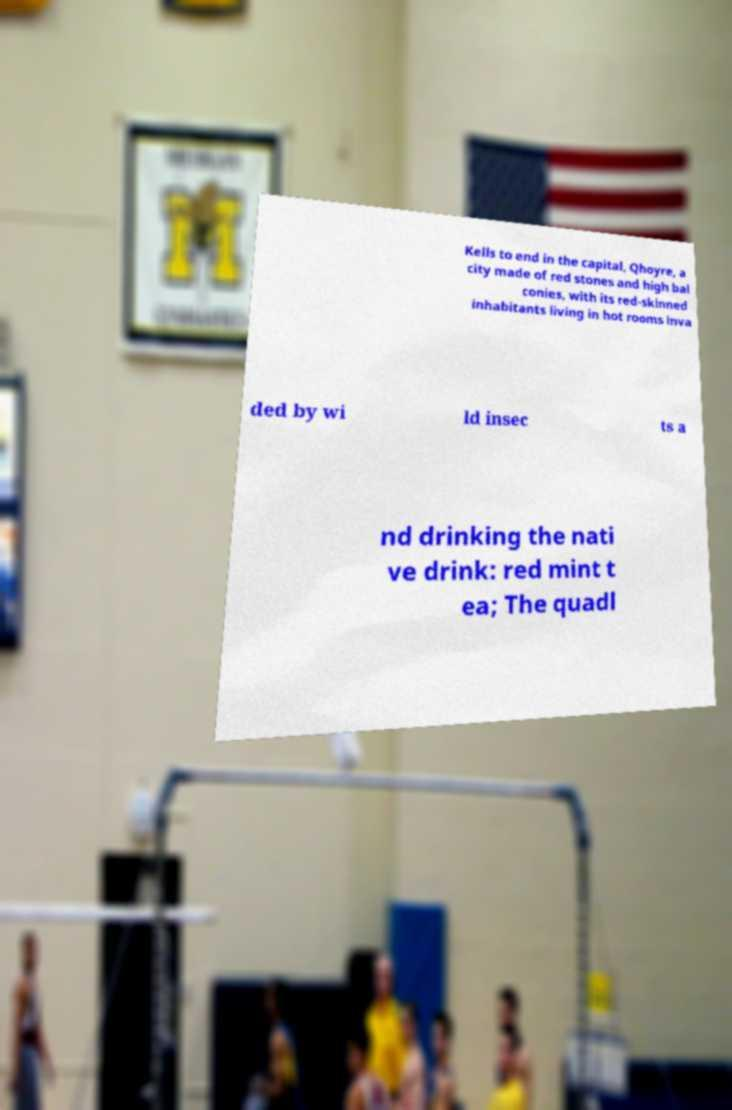Please read and relay the text visible in this image. What does it say? Kells to end in the capital, Qhoyre, a city made of red stones and high bal conies, with its red-skinned inhabitants living in hot rooms inva ded by wi ld insec ts a nd drinking the nati ve drink: red mint t ea; The quadl 